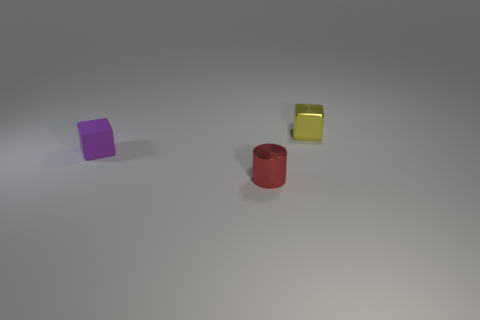Add 2 purple blocks. How many objects exist? 5 Subtract all cylinders. How many objects are left? 2 Subtract all yellow blocks. Subtract all small metallic cylinders. How many objects are left? 1 Add 1 tiny blocks. How many tiny blocks are left? 3 Add 2 tiny yellow things. How many tiny yellow things exist? 3 Subtract 0 blue spheres. How many objects are left? 3 